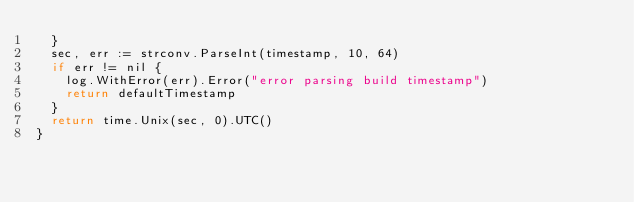Convert code to text. <code><loc_0><loc_0><loc_500><loc_500><_Go_>	}
	sec, err := strconv.ParseInt(timestamp, 10, 64)
	if err != nil {
		log.WithError(err).Error("error parsing build timestamp")
		return defaultTimestamp
	}
	return time.Unix(sec, 0).UTC()
}
</code> 